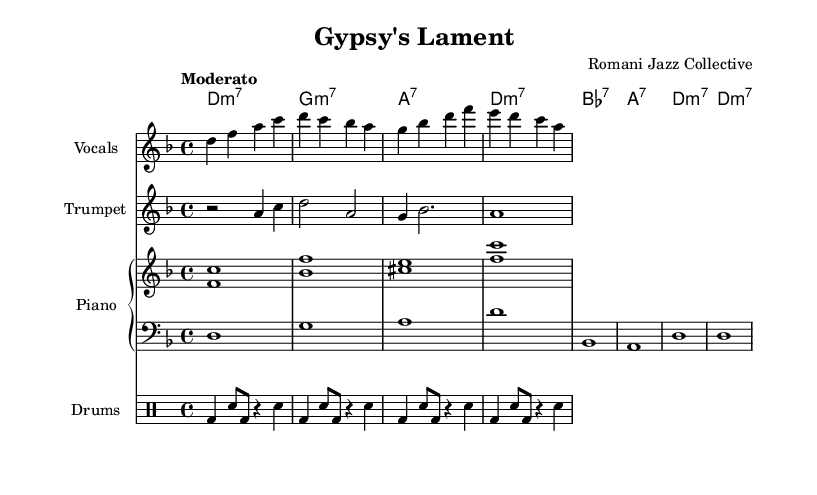What is the key signature of this music? The key signature is indicated at the beginning of the score, which is D minor. This can be inferred from the key signature with one flat.
Answer: D minor What is the time signature of the piece? The time signature is found at the beginning of the score and is written as 4/4, indicating four beats in each measure.
Answer: 4/4 What is the tempo marking of the score? The tempo marking is provided in Italian at the beginning of the score next to the tempo text, which reads "Moderato," indicating a moderate speed for the song.
Answer: Moderato How many measures does the vocal part contain? By counting the individual phrases in the vocal staff, each line corresponds to one measure, and this score has a total of 8 measures for the vocal part.
Answer: 8 measures What instrument is featured prominently in the intro of the piece? The trumpet part, labeled "Trumpet," plays a notable riff at the beginning, allowing it to be identified as a prominent instrumental feature.
Answer: Trumpet What kind of jazz is being represented in this piece? The song incorporates socially conscious themes evident from the lyrics that address social justice and human rights issues relevant to the Romani community.
Answer: Socially conscious jazz Which musical form is used in the chord progression? The chords indicated suggest a cyclical form, as they repeat within a standard jazz progression pattern typical in many jazz compositions.
Answer: Cyclical form 